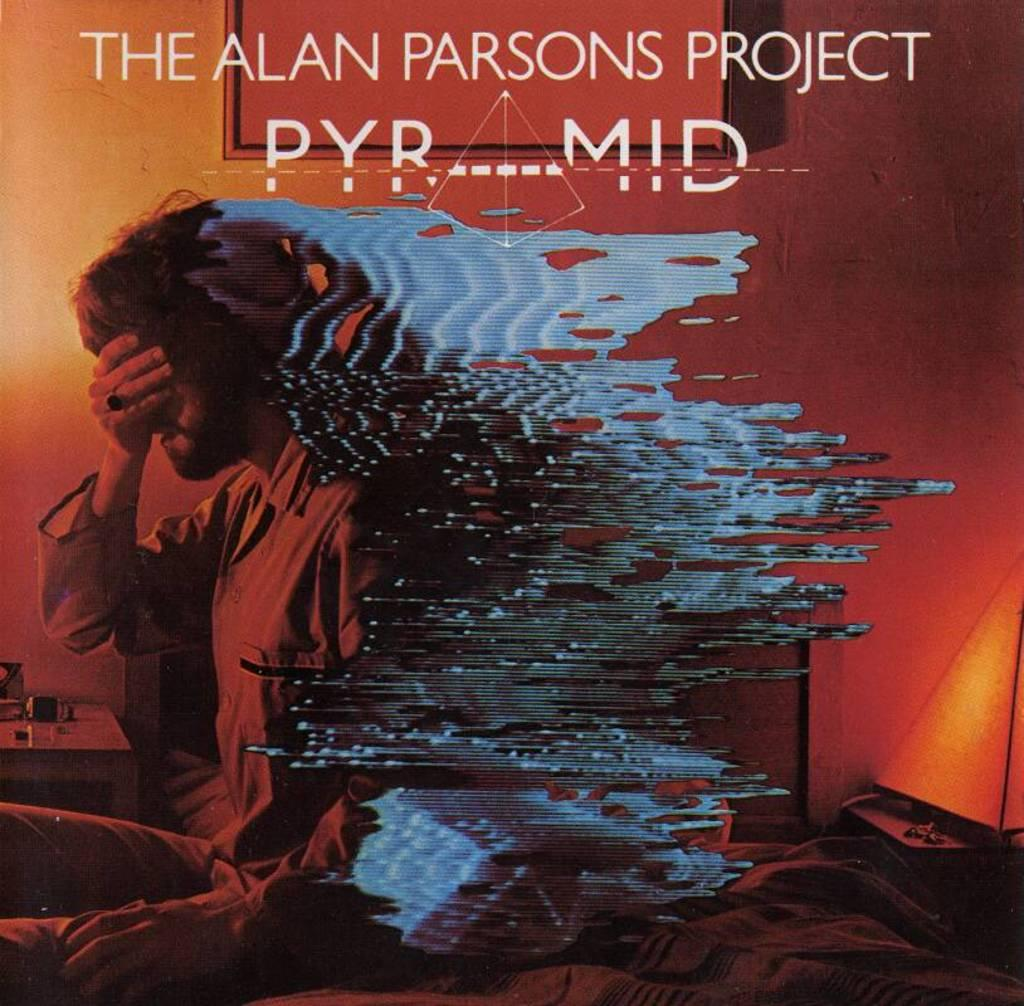What is the main subject of the image? There is a person on a bed in the image. What else can be seen in the image besides the person on the bed? There is a table, objects on the table, a wall, and text in the image. Can you describe the table in the image? There is a table in the image, but the specific details of the table are not mentioned in the facts. What type of text is present in the image? The facts mention that there is text in the image, but the specific content of the text is not provided. How many planes are flying over the person on the bed in the image? There are no planes visible in the image; it only shows a person on a bed, a table, objects on the table, a wall, and text. 